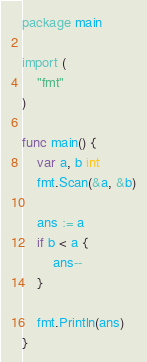Convert code to text. <code><loc_0><loc_0><loc_500><loc_500><_Go_>package main

import (
	"fmt"
)

func main() {
	var a, b int
	fmt.Scan(&a, &b)

	ans := a
	if b < a {
		ans--
	}

	fmt.Println(ans)
}
</code> 